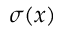<formula> <loc_0><loc_0><loc_500><loc_500>\sigma ( { x } )</formula> 